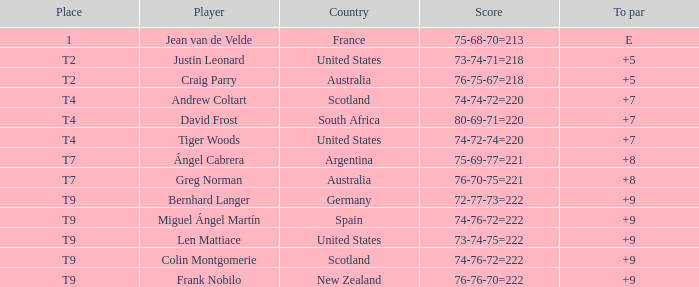What is the To Par score for the player from South Africa? 7.0. 